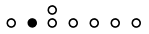<formula> <loc_0><loc_0><loc_500><loc_500>\begin{smallmatrix} & & \circ \\ \circ & \bullet & \circ & \circ & \circ & \circ & \circ & \\ \end{smallmatrix}</formula> 